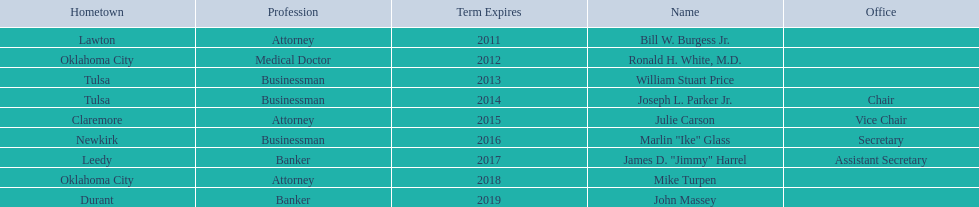Who are the state regents? Bill W. Burgess Jr., Ronald H. White, M.D., William Stuart Price, Joseph L. Parker Jr., Julie Carson, Marlin "Ike" Glass, James D. "Jimmy" Harrel, Mike Turpen, John Massey. Of those state regents, who is from the same hometown as ronald h. white, m.d.? Mike Turpen. 